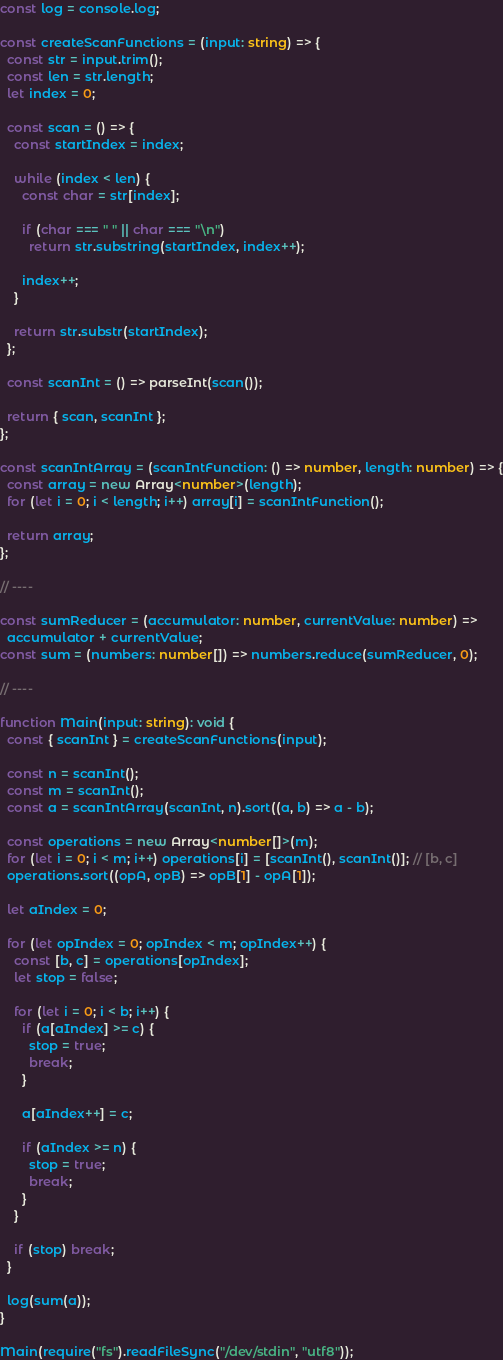<code> <loc_0><loc_0><loc_500><loc_500><_TypeScript_>const log = console.log;

const createScanFunctions = (input: string) => {
  const str = input.trim();
  const len = str.length;
  let index = 0;

  const scan = () => {
    const startIndex = index;

    while (index < len) {
      const char = str[index];

      if (char === " " || char === "\n")
        return str.substring(startIndex, index++);

      index++;
    }

    return str.substr(startIndex);
  };

  const scanInt = () => parseInt(scan());

  return { scan, scanInt };
};

const scanIntArray = (scanIntFunction: () => number, length: number) => {
  const array = new Array<number>(length);
  for (let i = 0; i < length; i++) array[i] = scanIntFunction();

  return array;
};

// ----

const sumReducer = (accumulator: number, currentValue: number) =>
  accumulator + currentValue;
const sum = (numbers: number[]) => numbers.reduce(sumReducer, 0);

// ----

function Main(input: string): void {
  const { scanInt } = createScanFunctions(input);

  const n = scanInt();
  const m = scanInt();
  const a = scanIntArray(scanInt, n).sort((a, b) => a - b);

  const operations = new Array<number[]>(m);
  for (let i = 0; i < m; i++) operations[i] = [scanInt(), scanInt()]; // [b, c]
  operations.sort((opA, opB) => opB[1] - opA[1]);

  let aIndex = 0;

  for (let opIndex = 0; opIndex < m; opIndex++) {
    const [b, c] = operations[opIndex];
    let stop = false;

    for (let i = 0; i < b; i++) {
      if (a[aIndex] >= c) {
        stop = true;
        break;
      }

      a[aIndex++] = c;

      if (aIndex >= n) {
        stop = true;
        break;
      }
    }

    if (stop) break;
  }

  log(sum(a));
}

Main(require("fs").readFileSync("/dev/stdin", "utf8"));
</code> 